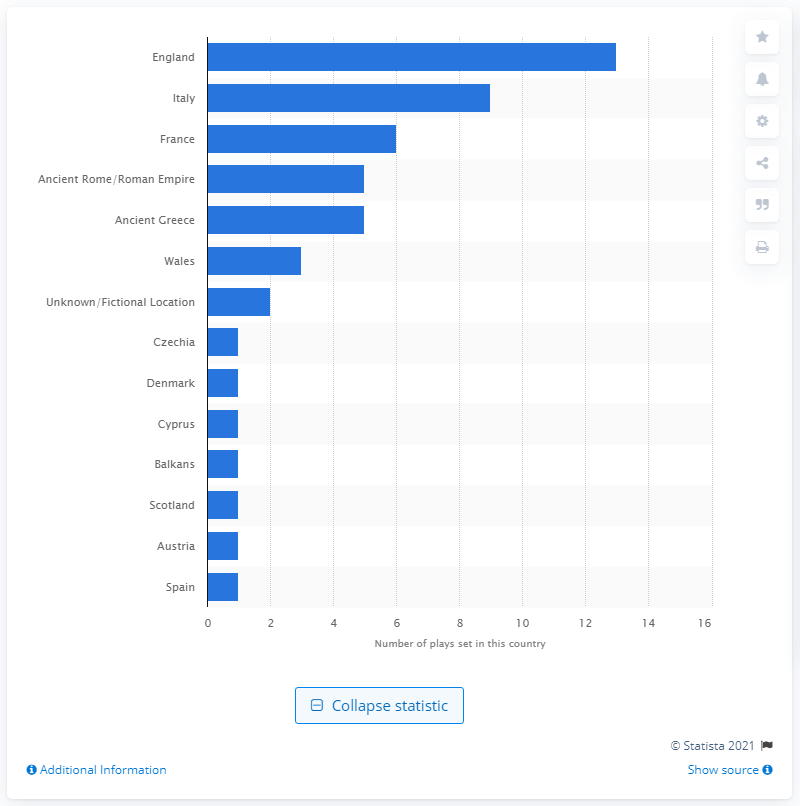Specify some key components in this picture. Shakespeare's canonized plays frequently take place in England, which is the most frequently used location. 